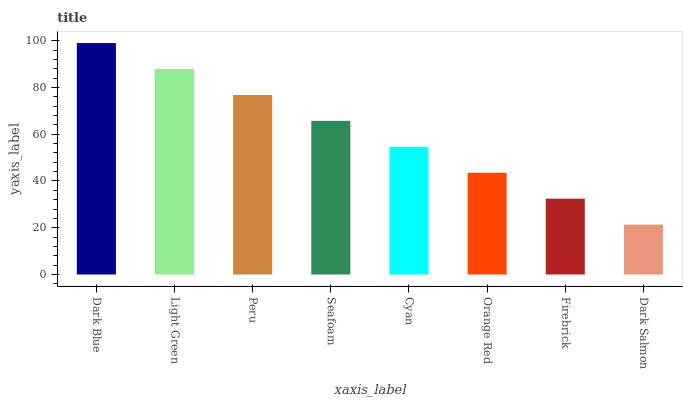Is Dark Salmon the minimum?
Answer yes or no. Yes. Is Dark Blue the maximum?
Answer yes or no. Yes. Is Light Green the minimum?
Answer yes or no. No. Is Light Green the maximum?
Answer yes or no. No. Is Dark Blue greater than Light Green?
Answer yes or no. Yes. Is Light Green less than Dark Blue?
Answer yes or no. Yes. Is Light Green greater than Dark Blue?
Answer yes or no. No. Is Dark Blue less than Light Green?
Answer yes or no. No. Is Seafoam the high median?
Answer yes or no. Yes. Is Cyan the low median?
Answer yes or no. Yes. Is Firebrick the high median?
Answer yes or no. No. Is Orange Red the low median?
Answer yes or no. No. 